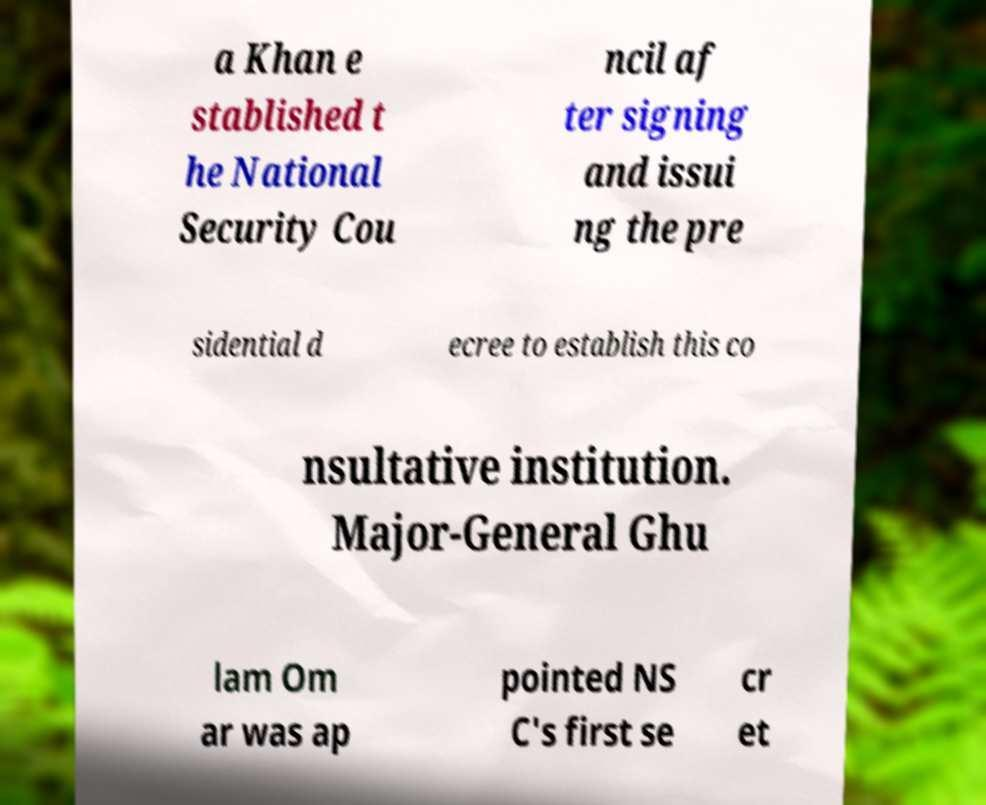Please identify and transcribe the text found in this image. a Khan e stablished t he National Security Cou ncil af ter signing and issui ng the pre sidential d ecree to establish this co nsultative institution. Major-General Ghu lam Om ar was ap pointed NS C's first se cr et 